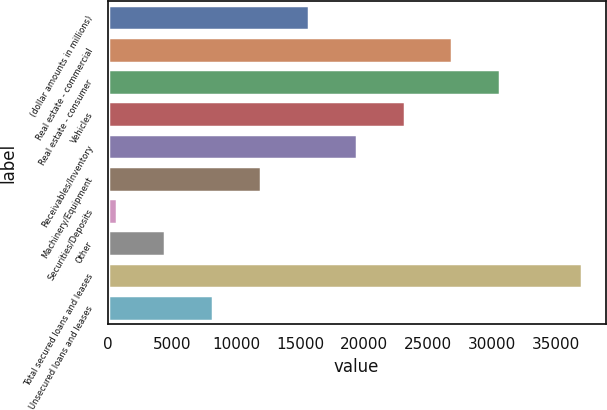Convert chart to OTSL. <chart><loc_0><loc_0><loc_500><loc_500><bar_chart><fcel>(dollar amounts in millions)<fcel>Real estate - commercial<fcel>Real estate - consumer<fcel>Vehicles<fcel>Receivables/Inventory<fcel>Machinery/Equipment<fcel>Securities/Deposits<fcel>Other<fcel>Total secured loans and leases<fcel>Unsecured loans and leases<nl><fcel>15683.2<fcel>26895.1<fcel>30632.4<fcel>23157.8<fcel>19420.5<fcel>11945.9<fcel>734<fcel>4471.3<fcel>36990<fcel>8208.6<nl></chart> 